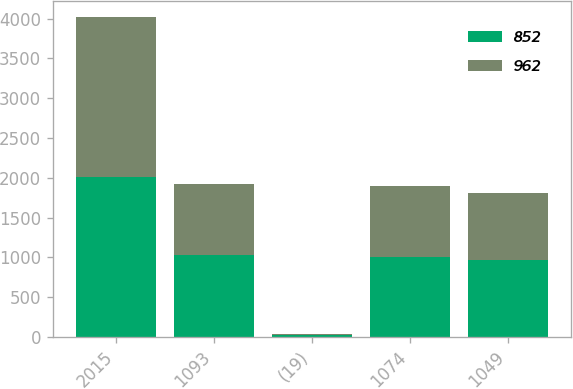<chart> <loc_0><loc_0><loc_500><loc_500><stacked_bar_chart><ecel><fcel>2015<fcel>1093<fcel>(19)<fcel>1074<fcel>1049<nl><fcel>852<fcel>2014<fcel>1025<fcel>17<fcel>1008<fcel>962<nl><fcel>962<fcel>2013<fcel>900<fcel>16<fcel>884<fcel>852<nl></chart> 